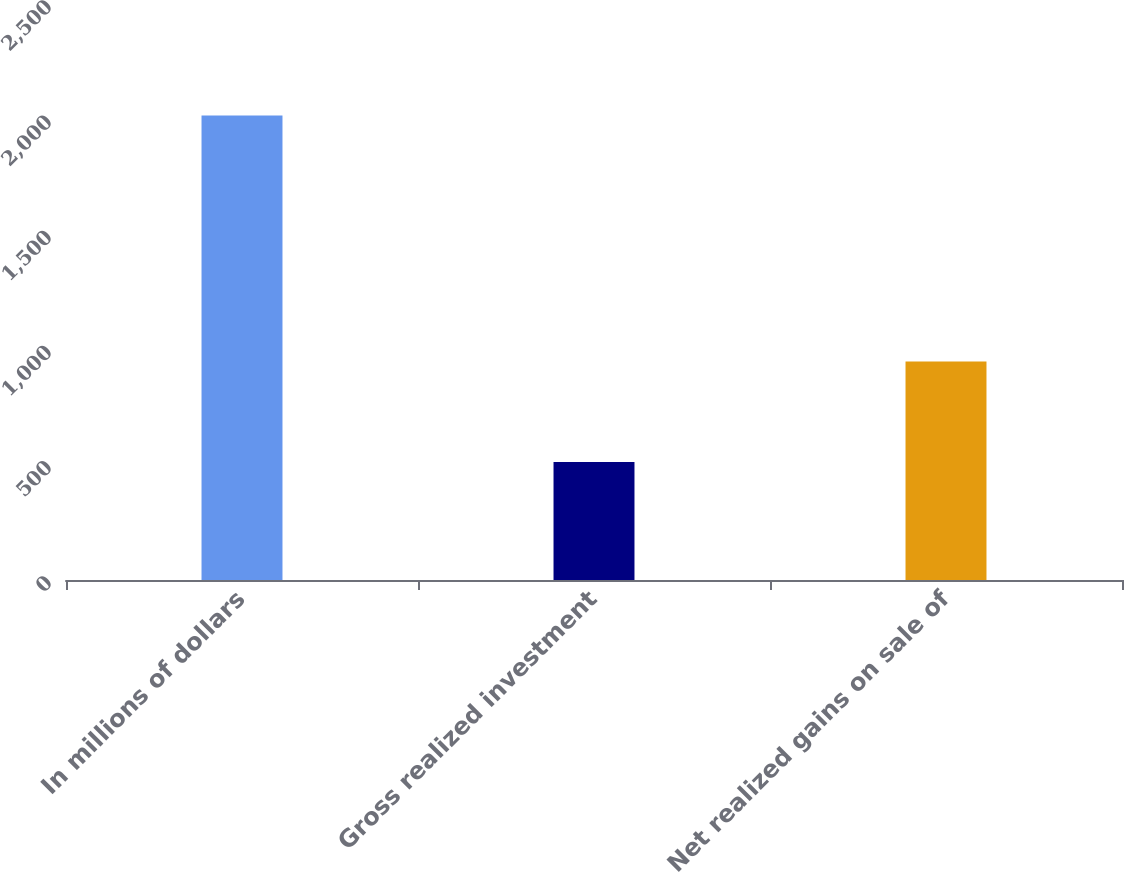Convert chart to OTSL. <chart><loc_0><loc_0><loc_500><loc_500><bar_chart><fcel>In millions of dollars<fcel>Gross realized investment<fcel>Net realized gains on sale of<nl><fcel>2016<fcel>512<fcel>948<nl></chart> 